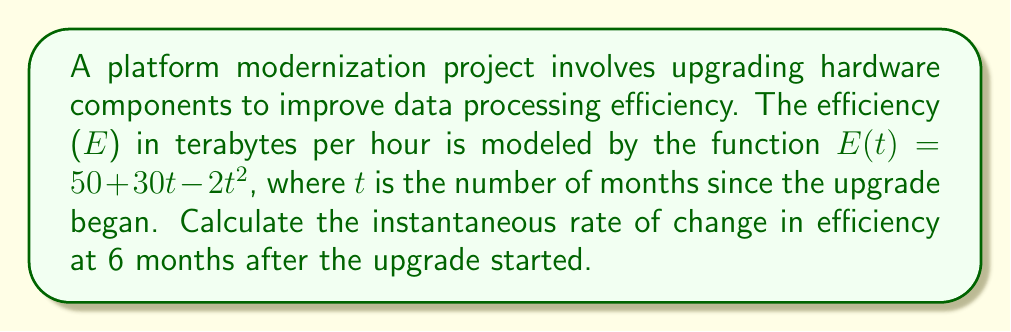Give your solution to this math problem. To find the instantaneous rate of change in efficiency at 6 months, we need to calculate the derivative of the efficiency function E(t) and evaluate it at t = 6.

Step 1: Find the derivative of E(t)
$$E(t) = 50 + 30t - 2t^2$$
$$E'(t) = 30 - 4t$$

Step 2: Evaluate E'(t) at t = 6
$$E'(6) = 30 - 4(6)$$
$$E'(6) = 30 - 24$$
$$E'(6) = 6$$

The instantaneous rate of change at t = 6 is 6 terabytes per hour per month.

Step 3: Interpret the result
This positive value indicates that the efficiency is still increasing at the 6-month mark, but at a slower rate than initially. The negative term in the derivative (-4t) suggests that the rate of increase is slowing down over time, which is typical in hardware upgrade scenarios due to diminishing returns.
Answer: 6 TB/hr/month 